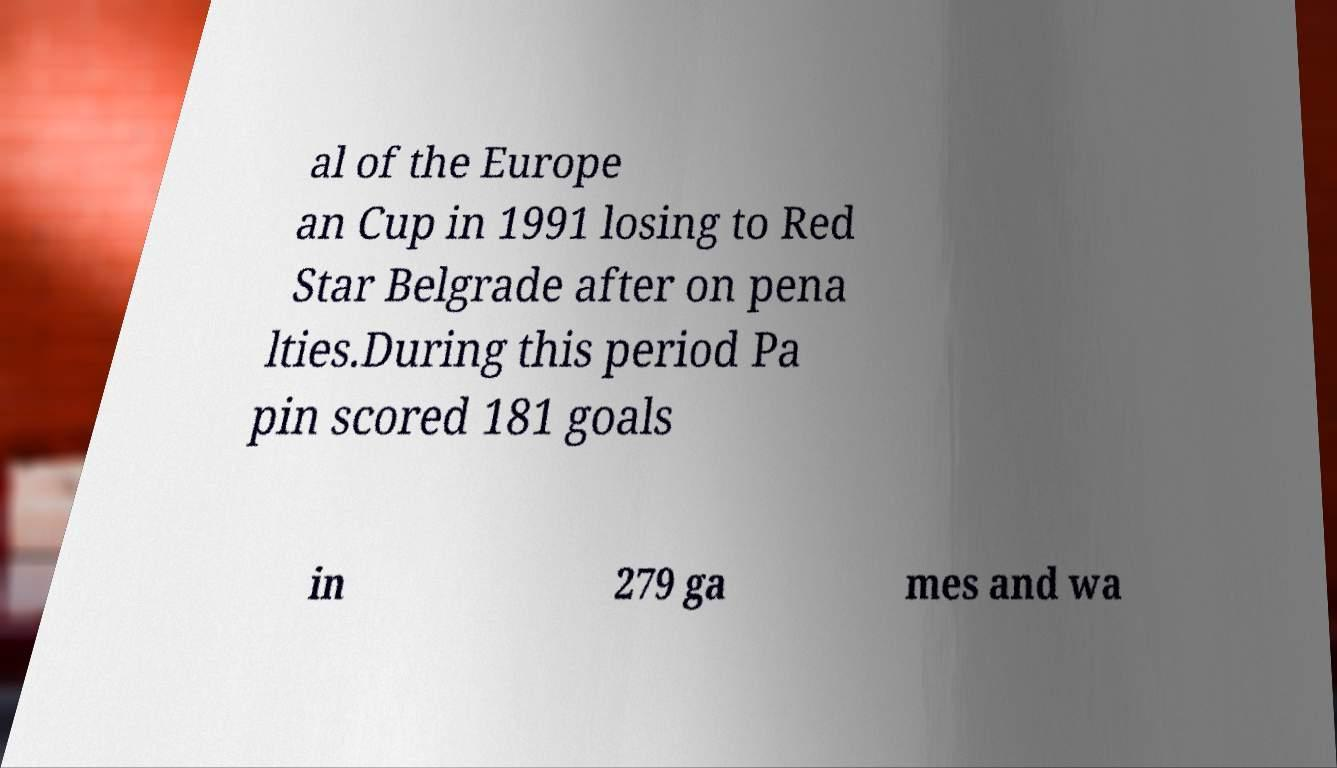Please read and relay the text visible in this image. What does it say? al of the Europe an Cup in 1991 losing to Red Star Belgrade after on pena lties.During this period Pa pin scored 181 goals in 279 ga mes and wa 